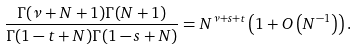<formula> <loc_0><loc_0><loc_500><loc_500>\frac { \Gamma ( \nu + N + 1 ) \Gamma ( N + 1 ) } { \Gamma ( 1 - t + N ) \Gamma ( 1 - s + N ) } = N ^ { \nu + s + t } \left ( 1 + O \left ( N ^ { - 1 } \right ) \right ) .</formula> 